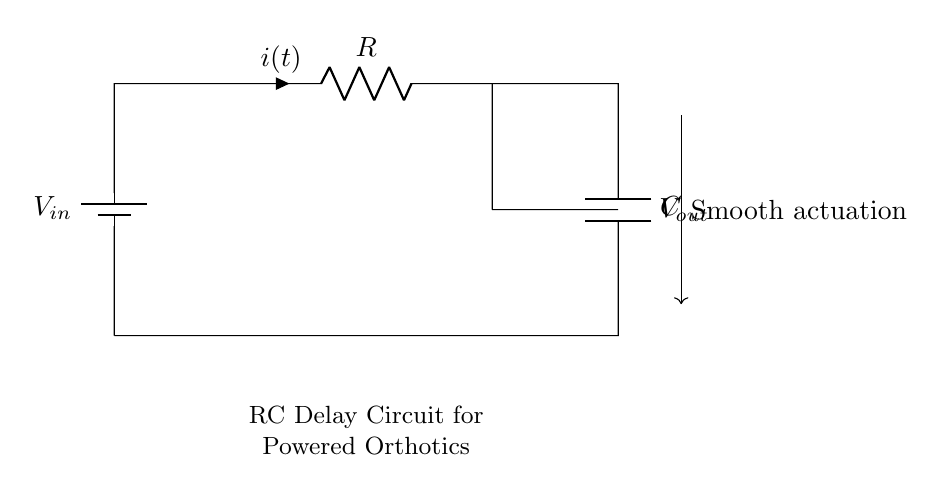What is the resistance in the circuit? The circuit shows a component labeled R, representing the resistance. The value of the resistance would need to be specified, but only R is indicated in the diagram.
Answer: R What is the capacitance in the circuit? The circuit contains a component labeled C, indicating the capacitance. Similar to resistance, the specific value is not shown, but it is simply indicated as C.
Answer: C What is the function of the capacitor in this circuit? The capacitor in an RC delay circuit is used to store electrical energy and smooth out the voltage changes, allowing for gradual actuation of powered orthotics.
Answer: Smoothing What does Vout represent? Vout is labeled in the circuit, indicating the output voltage across the capacitor, which depends on the charge of the capacitor and influences the actuation of the orthotics.
Answer: Output voltage How does the RC time constant affect actuation? The RC time constant, which is the product of resistance and capacitance (R*C), defines the time it takes for the capacitor to charge to about 63.2% of the input voltage, thereby controlling the speed of voltage transition and actuation response.
Answer: Time constant What is the current direction in the circuit? The current direction is indicated by the arrow labeled i(t), which shows the flow from the battery through the resistor and then into the capacitor.
Answer: From battery to capacitor Why is a smooth actuation necessary in powered orthotics? Smooth actuation is crucial to prevent abrupt movements which could lead to discomfort or malfunction during use. It allows for controlled and precise operation of the orthotics.
Answer: Prevents discomfort 